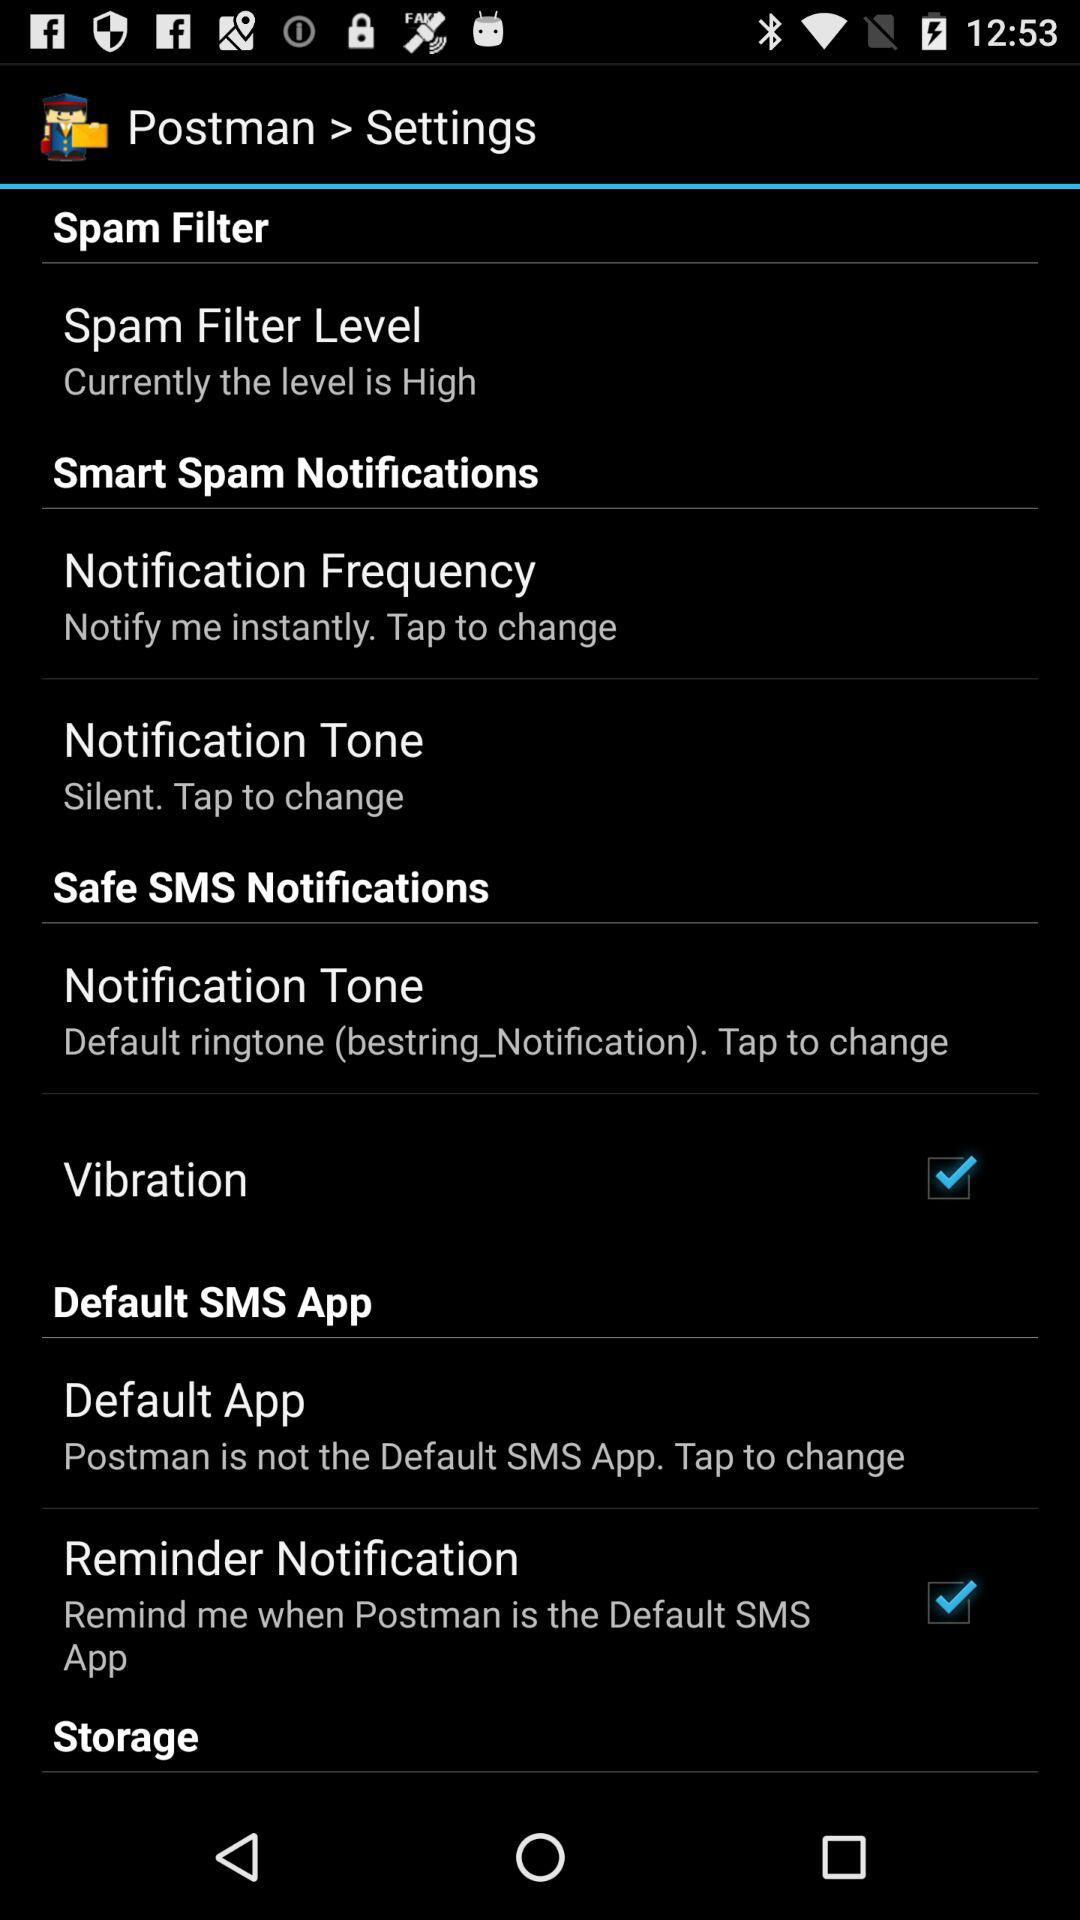Which setting is set to "Silent"? The setting that is set to "Silent" is "Notification Tone". 